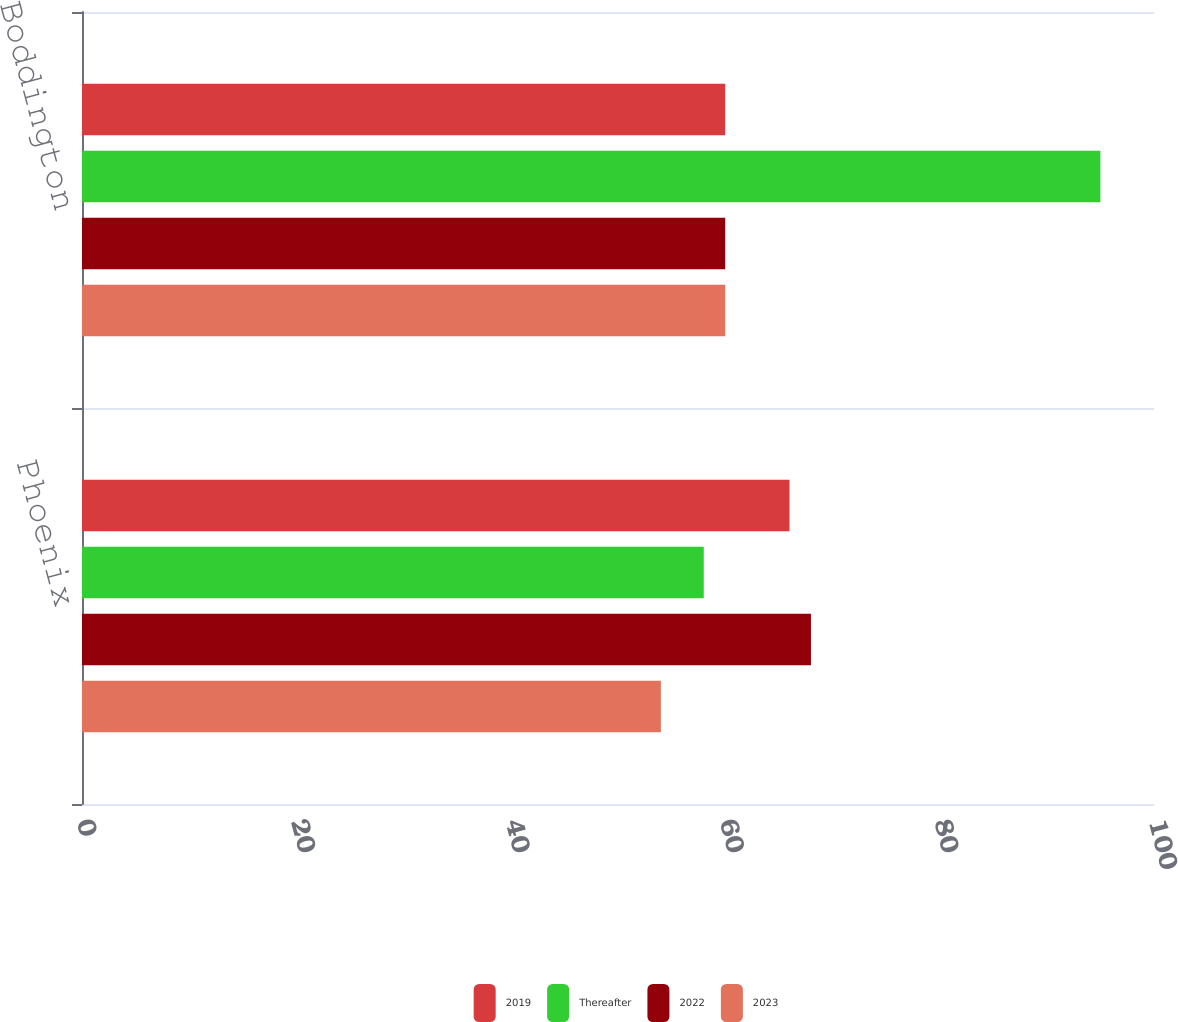<chart> <loc_0><loc_0><loc_500><loc_500><stacked_bar_chart><ecel><fcel>Phoenix<fcel>Boddington<nl><fcel>2019<fcel>66<fcel>60<nl><fcel>Thereafter<fcel>58<fcel>95<nl><fcel>2022<fcel>68<fcel>60<nl><fcel>2023<fcel>54<fcel>60<nl></chart> 